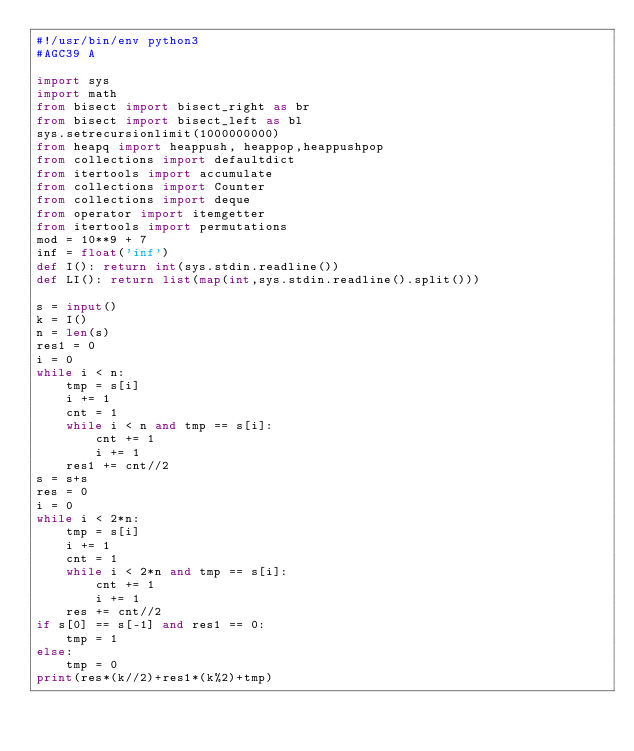<code> <loc_0><loc_0><loc_500><loc_500><_Python_>#!/usr/bin/env python3
#AGC39 A

import sys
import math
from bisect import bisect_right as br
from bisect import bisect_left as bl
sys.setrecursionlimit(1000000000)
from heapq import heappush, heappop,heappushpop
from collections import defaultdict
from itertools import accumulate
from collections import Counter
from collections import deque
from operator import itemgetter
from itertools import permutations
mod = 10**9 + 7
inf = float('inf')
def I(): return int(sys.stdin.readline())
def LI(): return list(map(int,sys.stdin.readline().split()))

s = input()
k = I()
n = len(s)
res1 = 0
i = 0
while i < n:
    tmp = s[i]
    i += 1
    cnt = 1
    while i < n and tmp == s[i]:
        cnt += 1
        i += 1
    res1 += cnt//2
s = s+s
res = 0
i = 0
while i < 2*n:
    tmp = s[i]
    i += 1
    cnt = 1
    while i < 2*n and tmp == s[i]:
        cnt += 1
        i += 1
    res += cnt//2
if s[0] == s[-1] and res1 == 0:
    tmp = 1
else:
    tmp = 0
print(res*(k//2)+res1*(k%2)+tmp)</code> 